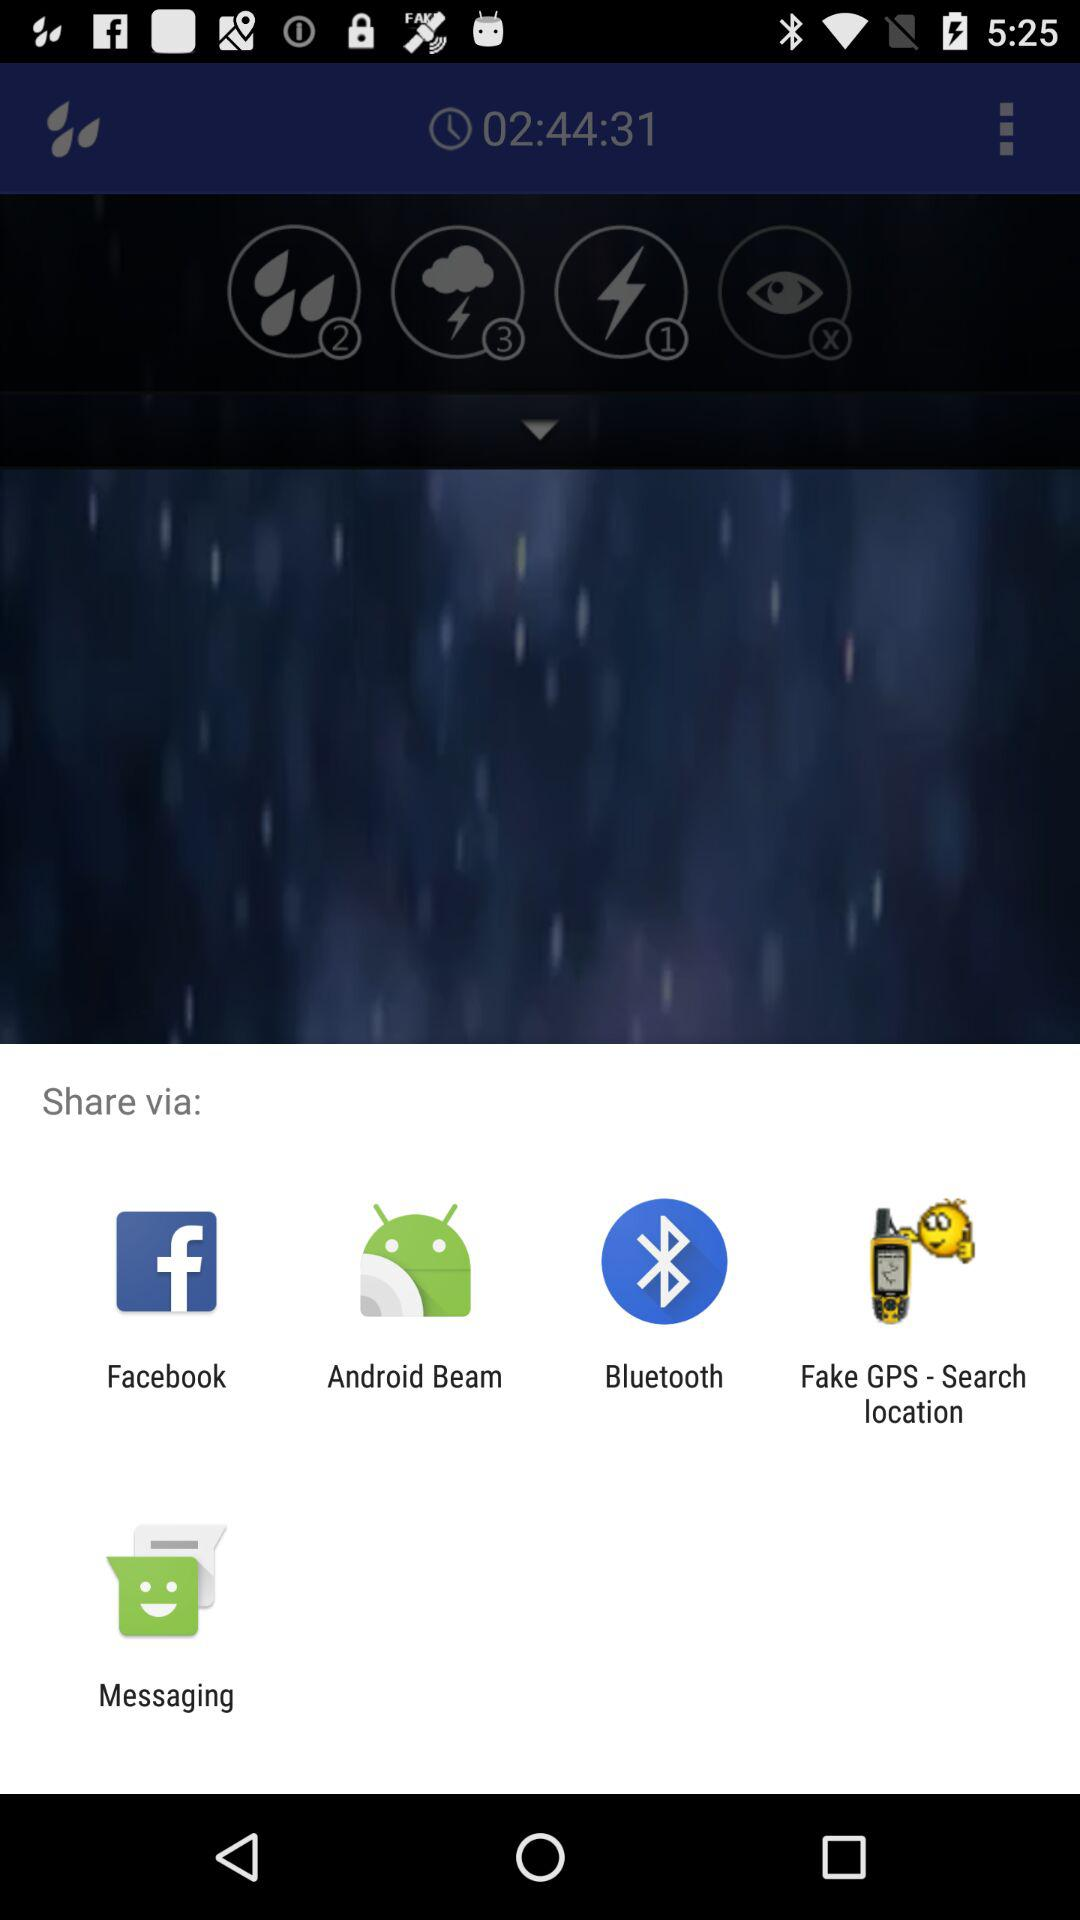What are the sharing options? The options are "Facebook", "Android Beam", "Bluetooth", "Fake GPS - Search location", and "Messaging". 